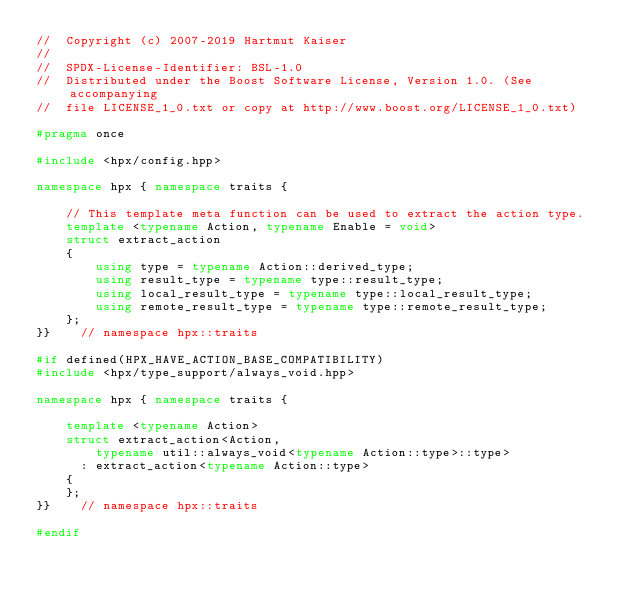<code> <loc_0><loc_0><loc_500><loc_500><_C++_>//  Copyright (c) 2007-2019 Hartmut Kaiser
//
//  SPDX-License-Identifier: BSL-1.0
//  Distributed under the Boost Software License, Version 1.0. (See accompanying
//  file LICENSE_1_0.txt or copy at http://www.boost.org/LICENSE_1_0.txt)

#pragma once

#include <hpx/config.hpp>

namespace hpx { namespace traits {

    // This template meta function can be used to extract the action type.
    template <typename Action, typename Enable = void>
    struct extract_action
    {
        using type = typename Action::derived_type;
        using result_type = typename type::result_type;
        using local_result_type = typename type::local_result_type;
        using remote_result_type = typename type::remote_result_type;
    };
}}    // namespace hpx::traits

#if defined(HPX_HAVE_ACTION_BASE_COMPATIBILITY)
#include <hpx/type_support/always_void.hpp>

namespace hpx { namespace traits {

    template <typename Action>
    struct extract_action<Action,
        typename util::always_void<typename Action::type>::type>
      : extract_action<typename Action::type>
    {
    };
}}    // namespace hpx::traits

#endif
</code> 